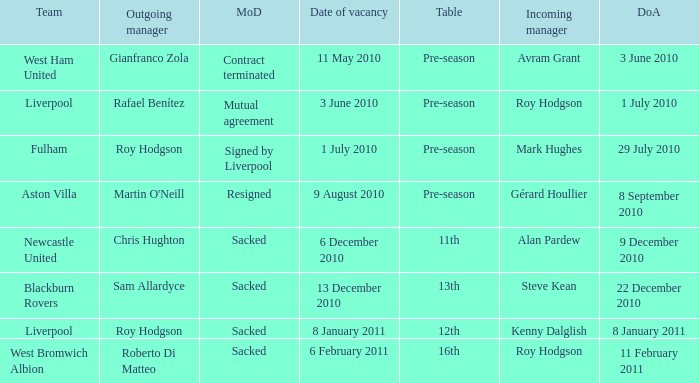What was the date of appointment for incoming manager Roy Hodgson and the team is Liverpool? 1 July 2010. 